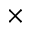Convert formula to latex. <formula><loc_0><loc_0><loc_500><loc_500>\times</formula> 